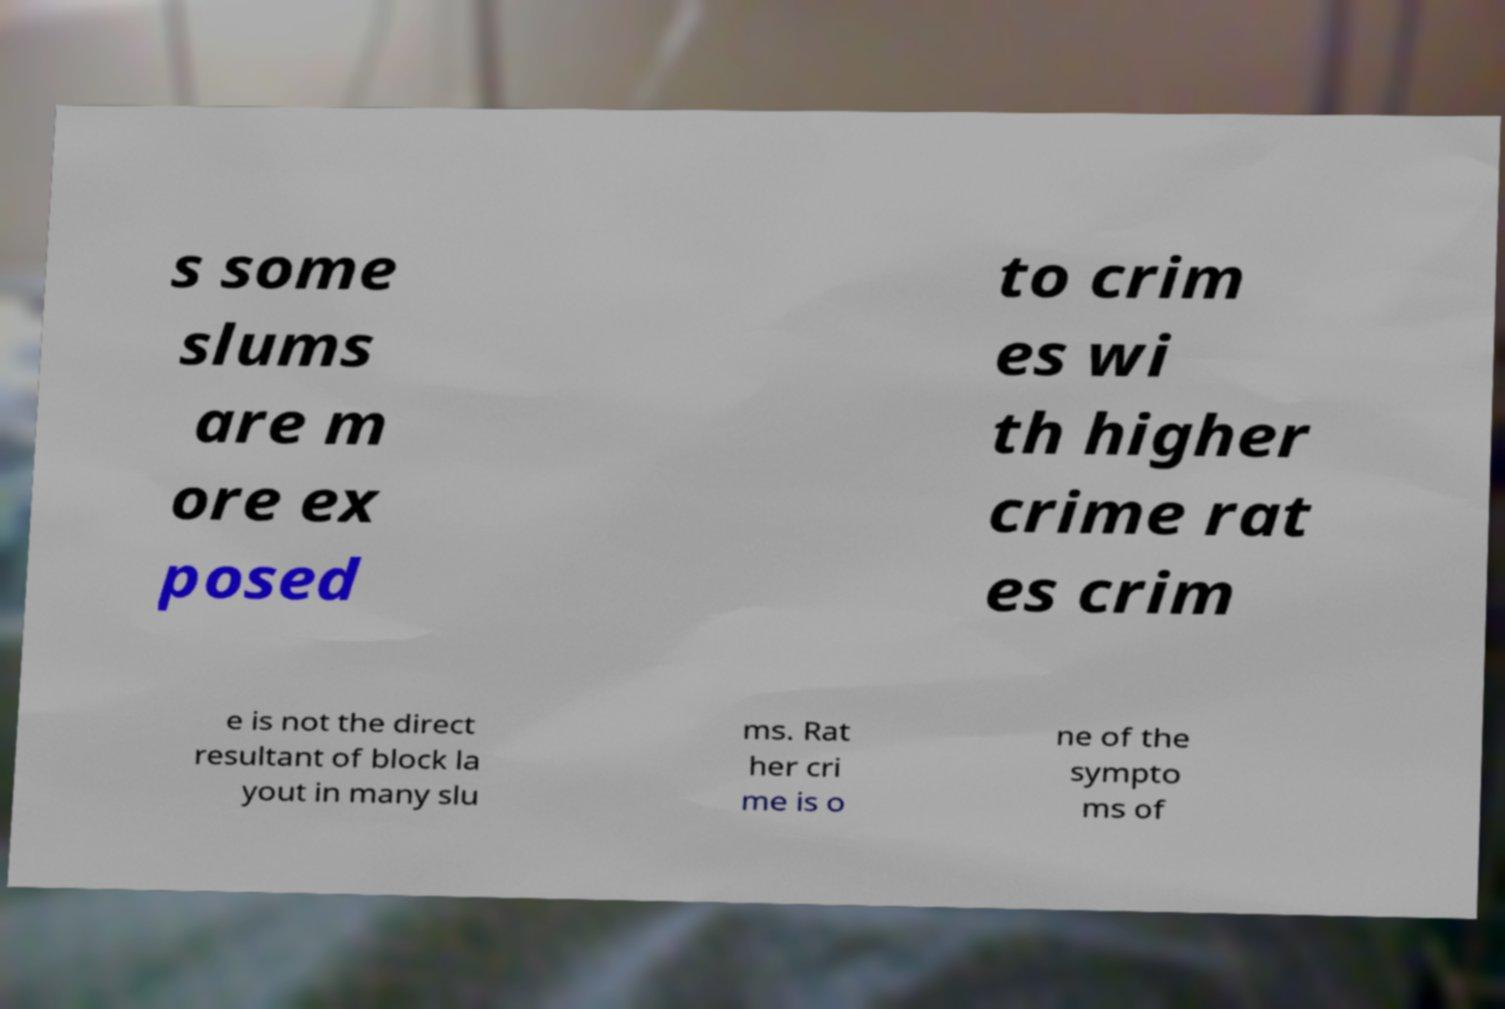I need the written content from this picture converted into text. Can you do that? s some slums are m ore ex posed to crim es wi th higher crime rat es crim e is not the direct resultant of block la yout in many slu ms. Rat her cri me is o ne of the sympto ms of 